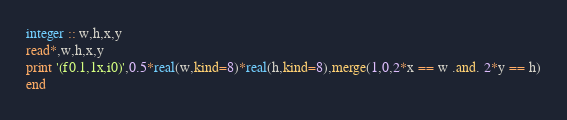Convert code to text. <code><loc_0><loc_0><loc_500><loc_500><_FORTRAN_>integer :: w,h,x,y
read*,w,h,x,y
print '(f0.1,1x,i0)',0.5*real(w,kind=8)*real(h,kind=8),merge(1,0,2*x == w .and. 2*y == h)
end</code> 